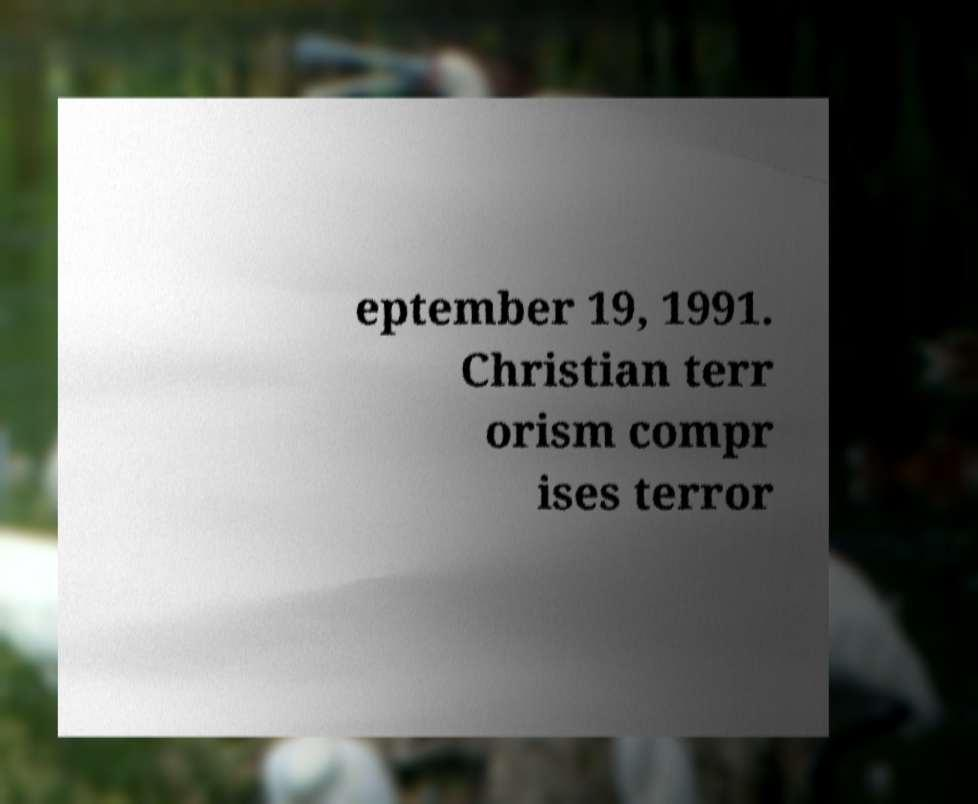For documentation purposes, I need the text within this image transcribed. Could you provide that? eptember 19, 1991. Christian terr orism compr ises terror 